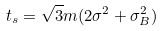<formula> <loc_0><loc_0><loc_500><loc_500>t _ { s } = \sqrt { 3 } m ( 2 \sigma ^ { 2 } + \sigma _ { B } ^ { 2 } )</formula> 